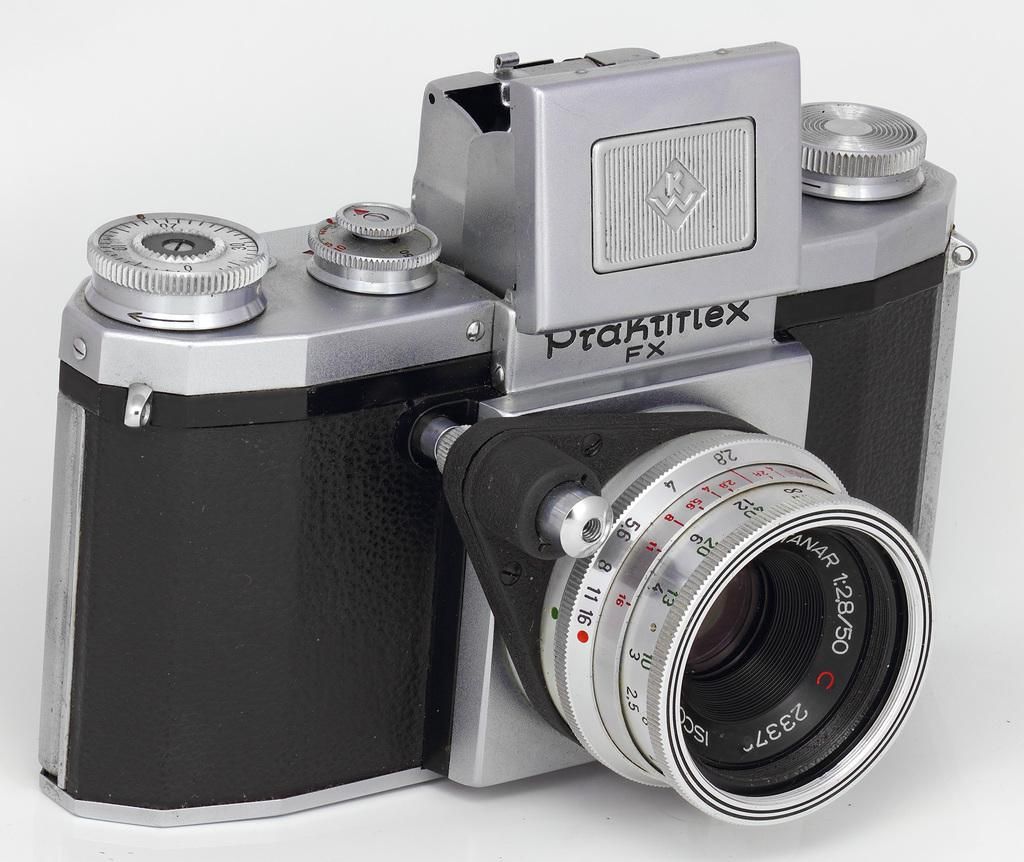What object is the main subject of the image? There is a camera in the image. Where is the camera located in the image? The camera is present on a surface. What additional information can be gathered from the camera in the image? There is text visible on the camera. How many elbows can be seen in the image? There are no elbows visible in the image. What type of number is associated with the cemetery in the image? There is no cemetery present in the image, so it is not possible to determine any associated numbers. 